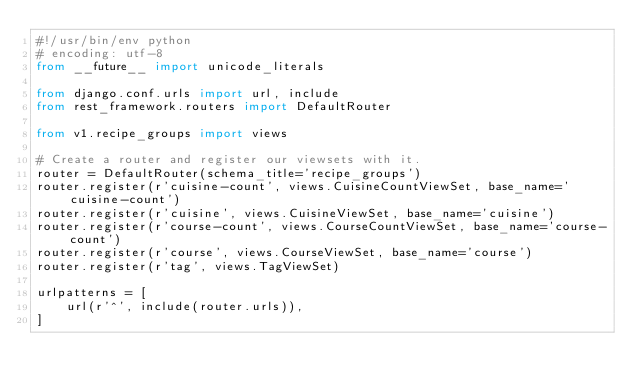Convert code to text. <code><loc_0><loc_0><loc_500><loc_500><_Python_>#!/usr/bin/env python
# encoding: utf-8
from __future__ import unicode_literals

from django.conf.urls import url, include
from rest_framework.routers import DefaultRouter

from v1.recipe_groups import views

# Create a router and register our viewsets with it.
router = DefaultRouter(schema_title='recipe_groups')
router.register(r'cuisine-count', views.CuisineCountViewSet, base_name='cuisine-count')
router.register(r'cuisine', views.CuisineViewSet, base_name='cuisine')
router.register(r'course-count', views.CourseCountViewSet, base_name='course-count')
router.register(r'course', views.CourseViewSet, base_name='course')
router.register(r'tag', views.TagViewSet)

urlpatterns = [
    url(r'^', include(router.urls)),
]
</code> 